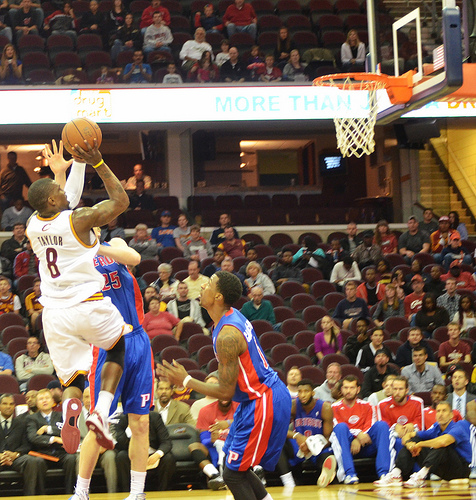<image>
Can you confirm if the man is on the man? Yes. Looking at the image, I can see the man is positioned on top of the man, with the man providing support. Is the ball above the man? Yes. The ball is positioned above the man in the vertical space, higher up in the scene. 